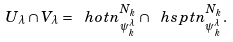Convert formula to latex. <formula><loc_0><loc_0><loc_500><loc_500>U _ { \lambda } \cap V _ { \lambda } = \ h o t n ^ { N _ { k } } _ { \psi _ { k } ^ { \lambda } } \cap \ h s p t n ^ { N _ { k } } _ { \psi _ { k } ^ { \lambda } } .</formula> 